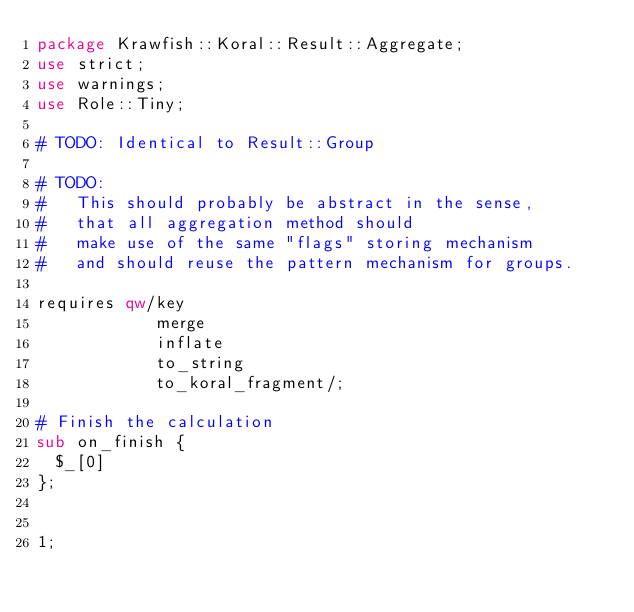Convert code to text. <code><loc_0><loc_0><loc_500><loc_500><_Perl_>package Krawfish::Koral::Result::Aggregate;
use strict;
use warnings;
use Role::Tiny;

# TODO: Identical to Result::Group

# TODO:
#   This should probably be abstract in the sense,
#   that all aggregation method should
#   make use of the same "flags" storing mechanism
#   and should reuse the pattern mechanism for groups.

requires qw/key
            merge
            inflate
            to_string
            to_koral_fragment/;

# Finish the calculation
sub on_finish {
  $_[0]
};


1;
</code> 